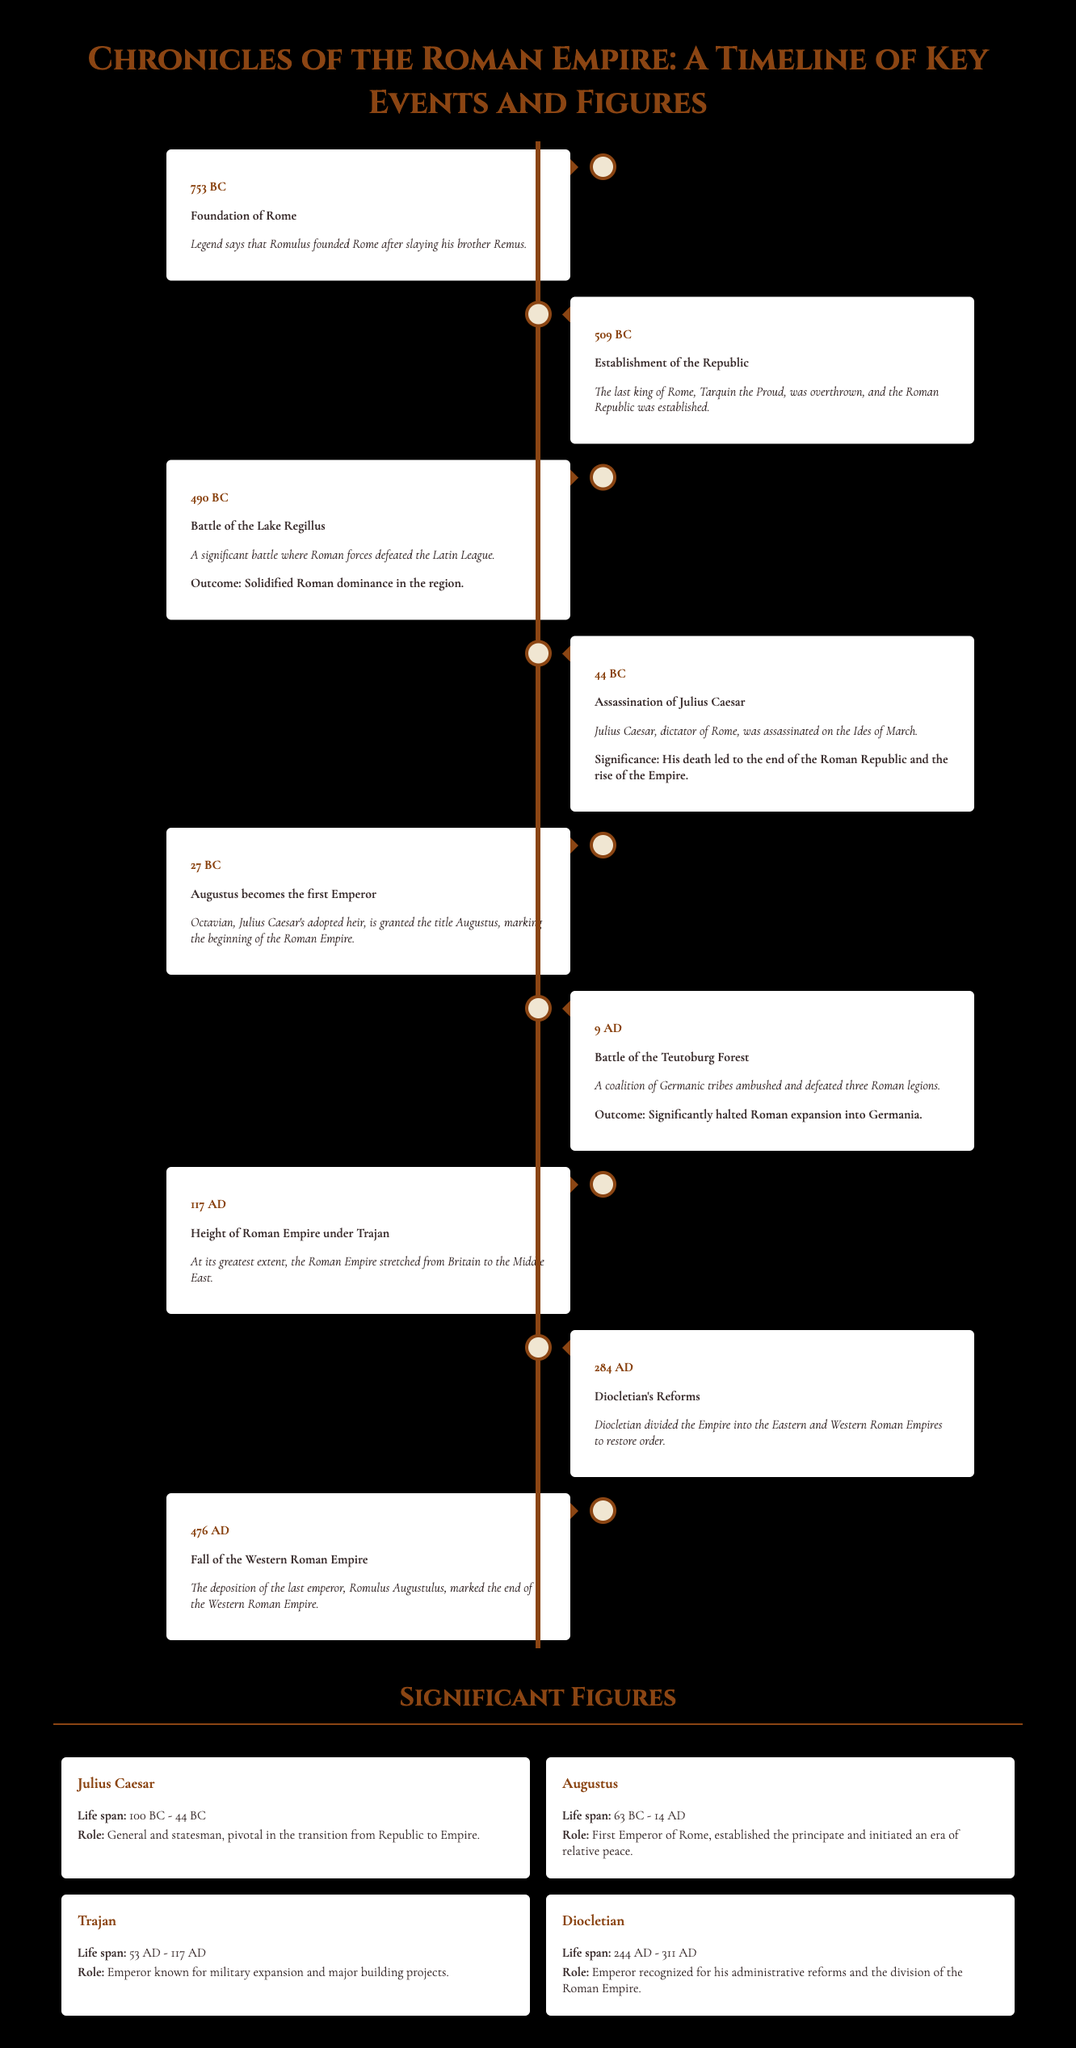What year was the Battle of the Teutoburg Forest? The Battle of the Teutoburg Forest occurred in the year 9 AD as indicated in the timeline.
Answer: 9 AD Who was the first Emperor of Rome? The document states that Augustus became the first Emperor of Rome, which is highlighted in his entry.
Answer: Augustus What event marked the end of the Western Roman Empire? The deposition of the last emperor, Romulus Augustulus in 476 AD, marked the end of the Western Roman Empire according to the timeline.
Answer: Fall of the Western Roman Empire In what year was Julius Caesar assassinated? The document specifies that Julius Caesar was assassinated in the year 44 BC on the Ides of March.
Answer: 44 BC What significant battle solidified Roman dominance over the Latin League? The Battle of the Lake Regillus was significant in solidifying Roman dominance over the Latin League as mentioned in the text.
Answer: Battle of the Lake Regillus What was Trajan known for? Trajan was known for military expansion and major building projects as described in his figure section.
Answer: Military expansion and major building projects Why was Diocletian significant? Diocletian is recognized for his administrative reforms and the division of the Roman Empire, which is detailed in his biography.
Answer: Administrative reforms and division of the Roman Empire What year did Rome face the height of its Empire under Trajan? The document notes that the height of the Roman Empire occurred in 117 AD under Trajan.
Answer: 117 AD 